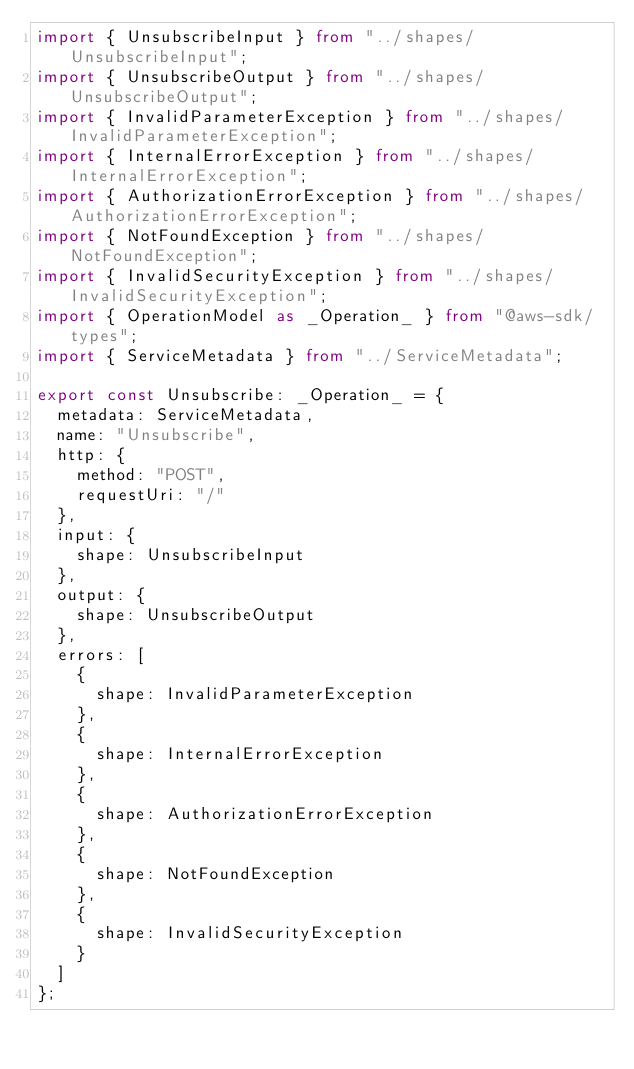Convert code to text. <code><loc_0><loc_0><loc_500><loc_500><_TypeScript_>import { UnsubscribeInput } from "../shapes/UnsubscribeInput";
import { UnsubscribeOutput } from "../shapes/UnsubscribeOutput";
import { InvalidParameterException } from "../shapes/InvalidParameterException";
import { InternalErrorException } from "../shapes/InternalErrorException";
import { AuthorizationErrorException } from "../shapes/AuthorizationErrorException";
import { NotFoundException } from "../shapes/NotFoundException";
import { InvalidSecurityException } from "../shapes/InvalidSecurityException";
import { OperationModel as _Operation_ } from "@aws-sdk/types";
import { ServiceMetadata } from "../ServiceMetadata";

export const Unsubscribe: _Operation_ = {
  metadata: ServiceMetadata,
  name: "Unsubscribe",
  http: {
    method: "POST",
    requestUri: "/"
  },
  input: {
    shape: UnsubscribeInput
  },
  output: {
    shape: UnsubscribeOutput
  },
  errors: [
    {
      shape: InvalidParameterException
    },
    {
      shape: InternalErrorException
    },
    {
      shape: AuthorizationErrorException
    },
    {
      shape: NotFoundException
    },
    {
      shape: InvalidSecurityException
    }
  ]
};
</code> 